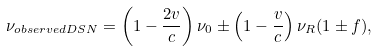Convert formula to latex. <formula><loc_0><loc_0><loc_500><loc_500>\nu _ { o b s e r v e d D S N } = \left ( 1 - \frac { 2 v } { c } \right ) \nu _ { 0 } \pm \left ( 1 - \frac { v } { c } \right ) \nu _ { R } ( 1 \pm f ) ,</formula> 